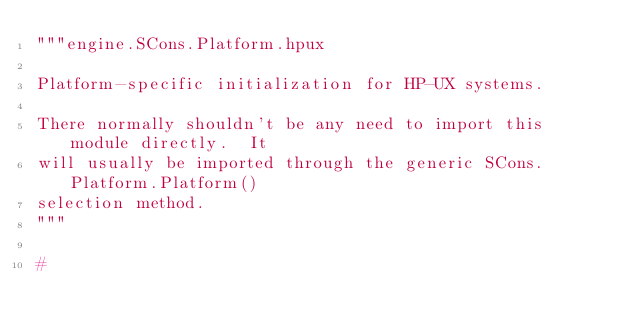Convert code to text. <code><loc_0><loc_0><loc_500><loc_500><_Python_>"""engine.SCons.Platform.hpux

Platform-specific initialization for HP-UX systems.

There normally shouldn't be any need to import this module directly.  It
will usually be imported through the generic SCons.Platform.Platform()
selection method.
"""

#</code> 